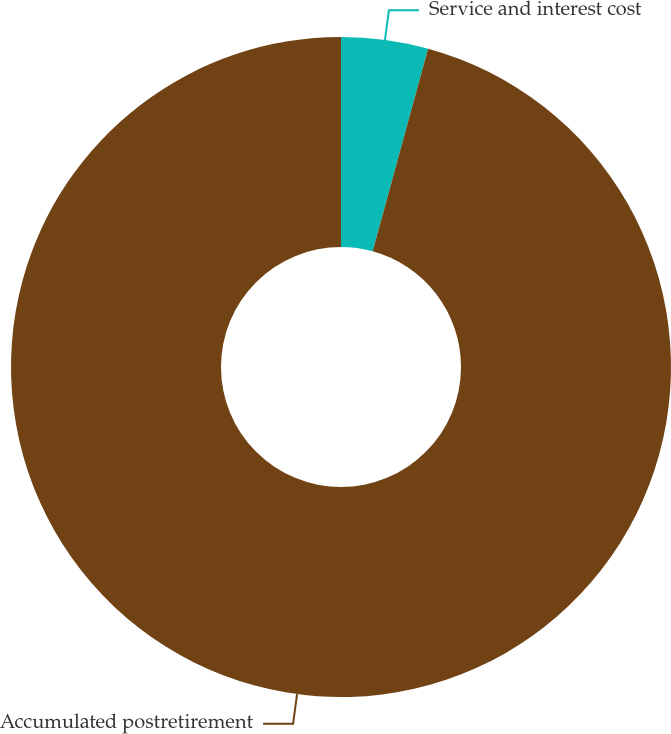<chart> <loc_0><loc_0><loc_500><loc_500><pie_chart><fcel>Service and interest cost<fcel>Accumulated postretirement<nl><fcel>4.25%<fcel>95.75%<nl></chart> 